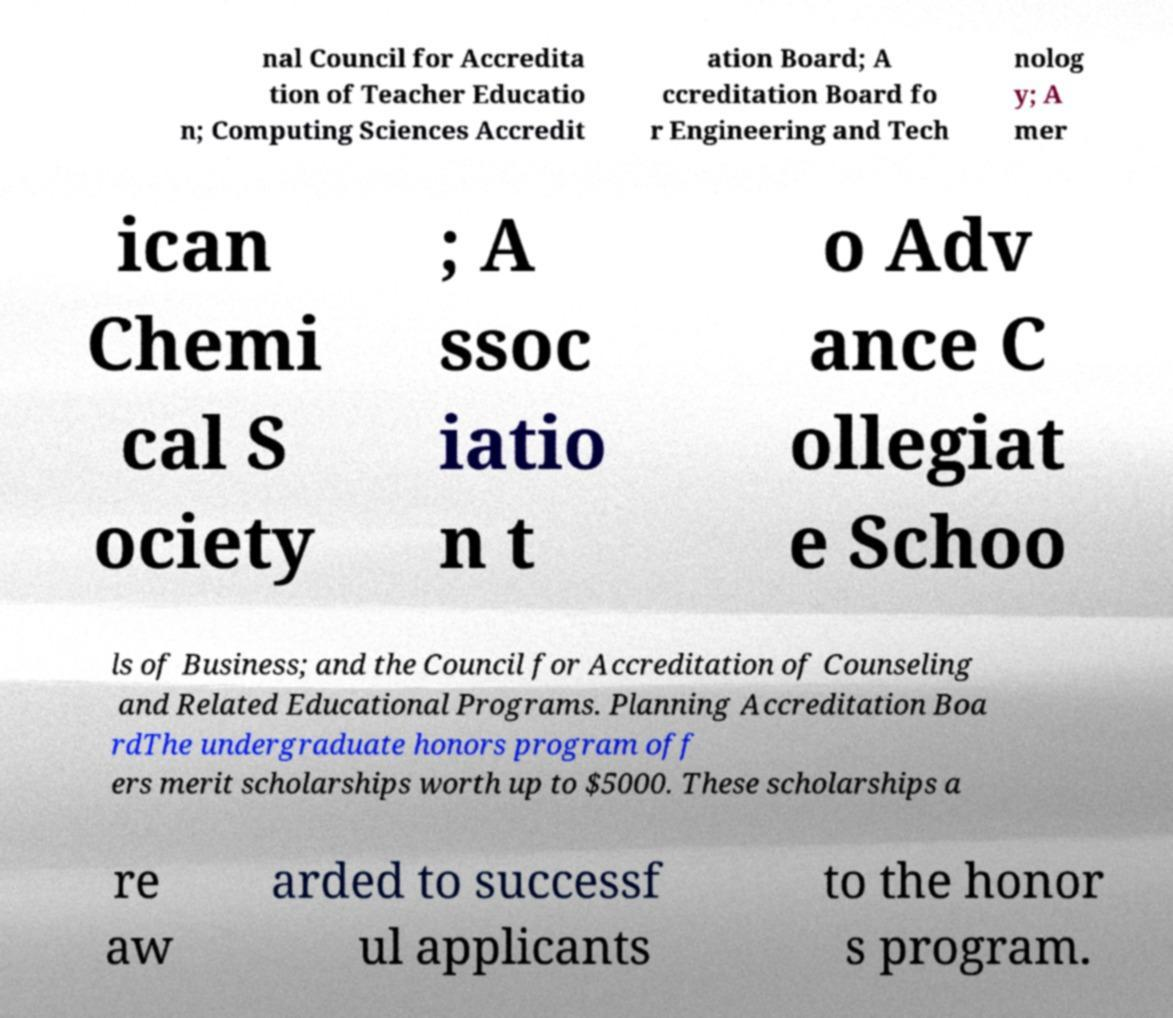What messages or text are displayed in this image? I need them in a readable, typed format. nal Council for Accredita tion of Teacher Educatio n; Computing Sciences Accredit ation Board; A ccreditation Board fo r Engineering and Tech nolog y; A mer ican Chemi cal S ociety ; A ssoc iatio n t o Adv ance C ollegiat e Schoo ls of Business; and the Council for Accreditation of Counseling and Related Educational Programs. Planning Accreditation Boa rdThe undergraduate honors program off ers merit scholarships worth up to $5000. These scholarships a re aw arded to successf ul applicants to the honor s program. 